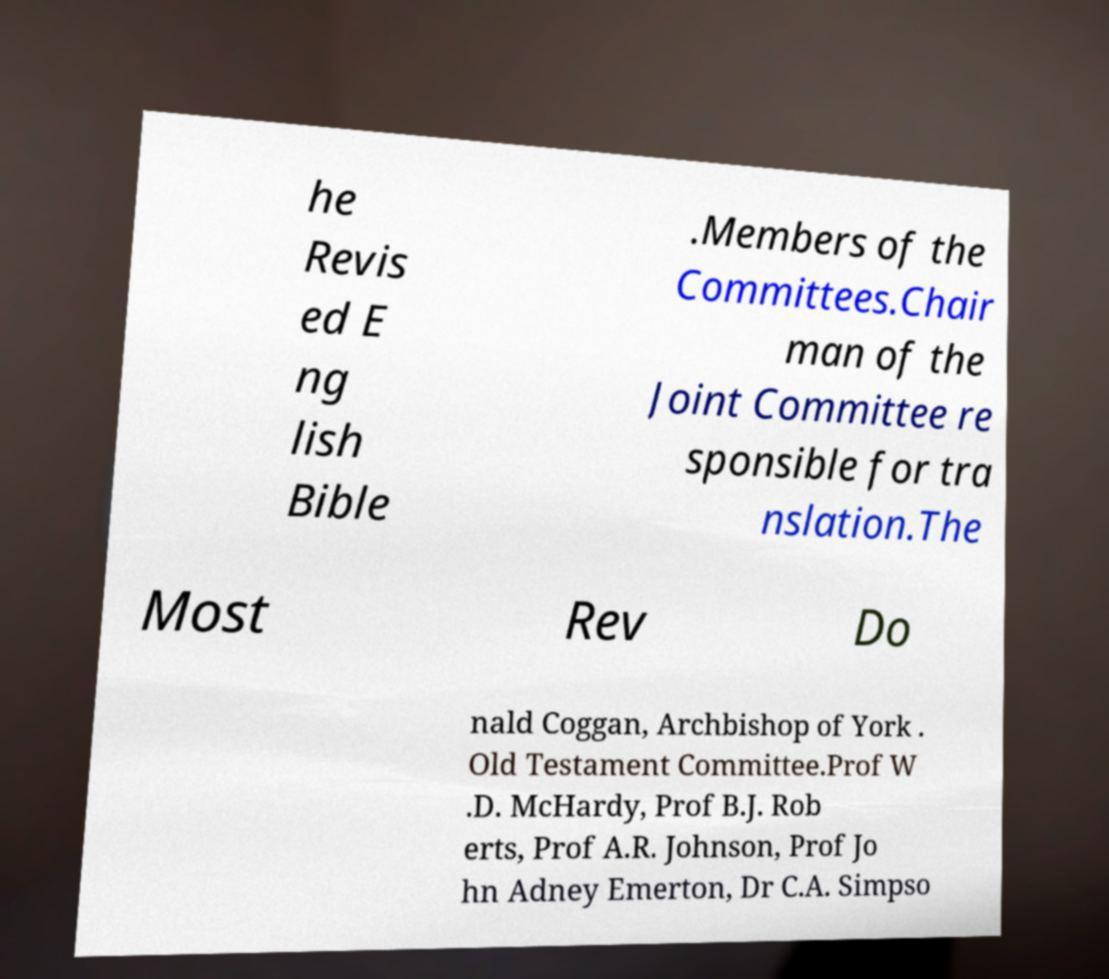There's text embedded in this image that I need extracted. Can you transcribe it verbatim? he Revis ed E ng lish Bible .Members of the Committees.Chair man of the Joint Committee re sponsible for tra nslation.The Most Rev Do nald Coggan, Archbishop of York . Old Testament Committee.Prof W .D. McHardy, Prof B.J. Rob erts, Prof A.R. Johnson, Prof Jo hn Adney Emerton, Dr C.A. Simpso 